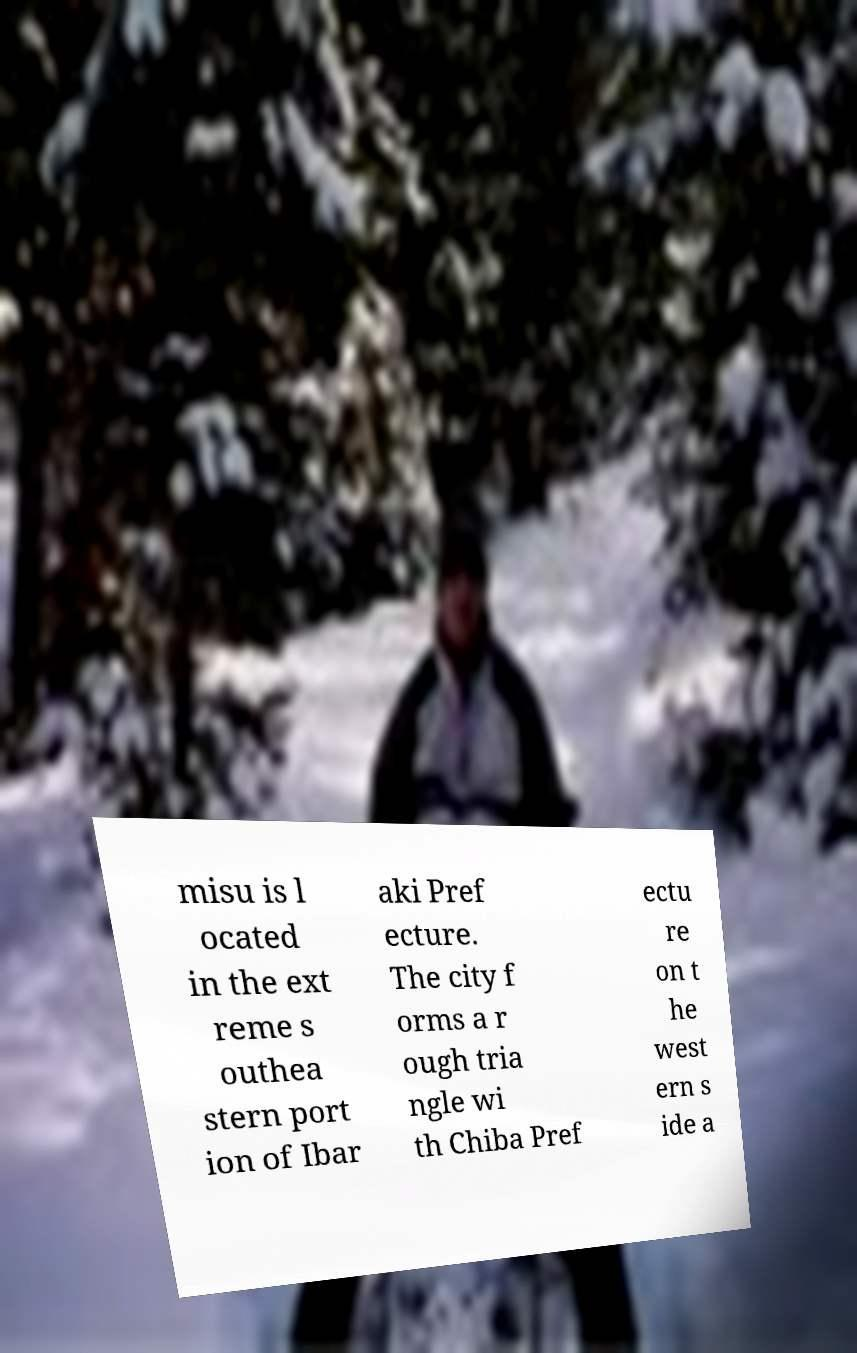There's text embedded in this image that I need extracted. Can you transcribe it verbatim? misu is l ocated in the ext reme s outhea stern port ion of Ibar aki Pref ecture. The city f orms a r ough tria ngle wi th Chiba Pref ectu re on t he west ern s ide a 